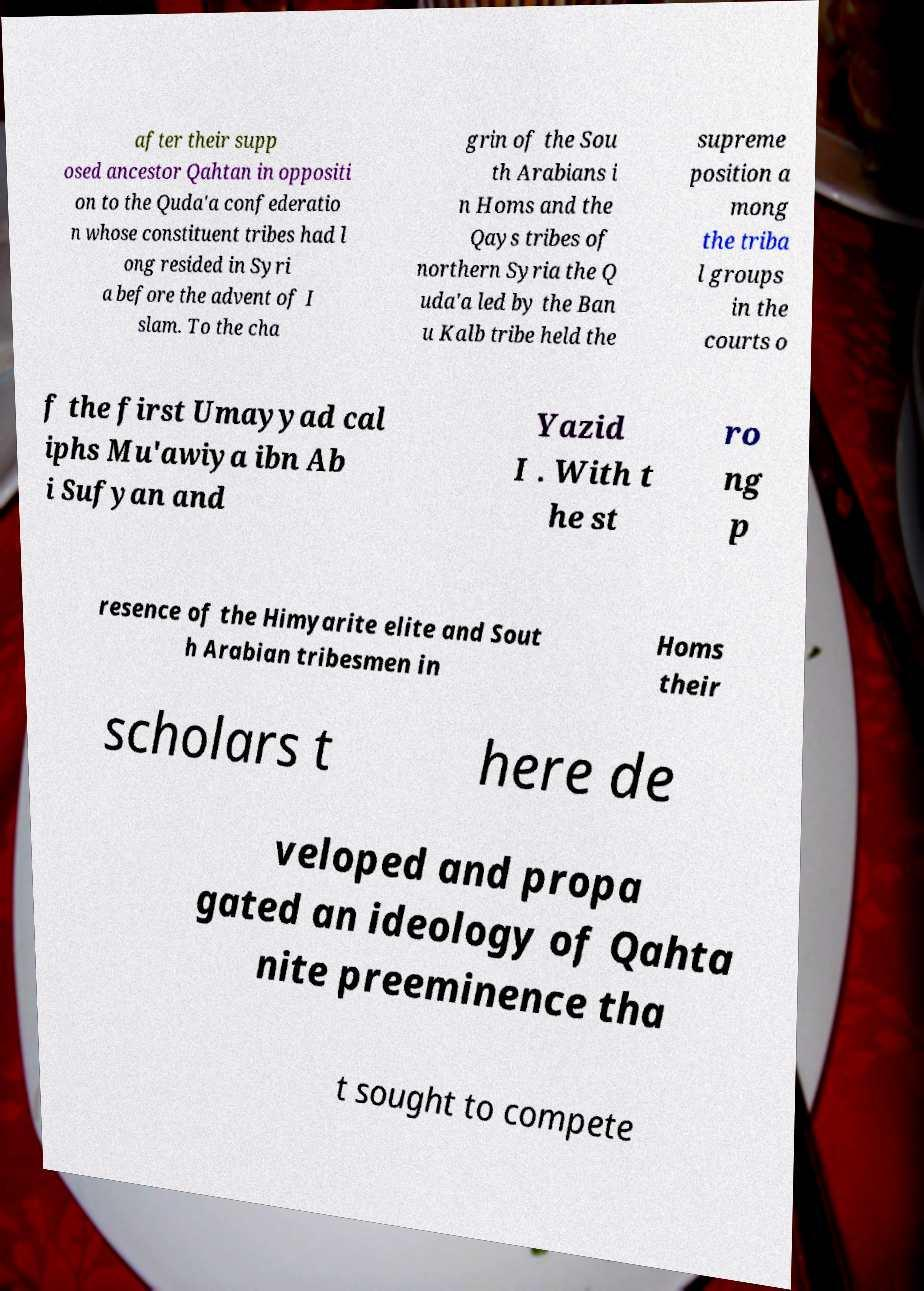Could you assist in decoding the text presented in this image and type it out clearly? after their supp osed ancestor Qahtan in oppositi on to the Quda'a confederatio n whose constituent tribes had l ong resided in Syri a before the advent of I slam. To the cha grin of the Sou th Arabians i n Homs and the Qays tribes of northern Syria the Q uda'a led by the Ban u Kalb tribe held the supreme position a mong the triba l groups in the courts o f the first Umayyad cal iphs Mu'awiya ibn Ab i Sufyan and Yazid I . With t he st ro ng p resence of the Himyarite elite and Sout h Arabian tribesmen in Homs their scholars t here de veloped and propa gated an ideology of Qahta nite preeminence tha t sought to compete 